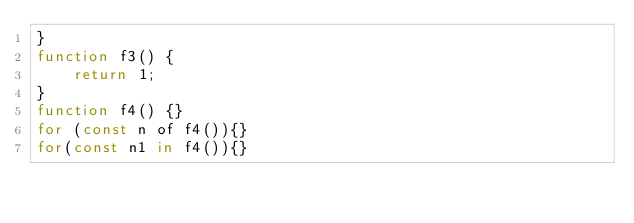<code> <loc_0><loc_0><loc_500><loc_500><_JavaScript_>}
function f3() {
    return 1;
}
function f4() {}
for (const n of f4()){}
for(const n1 in f4()){}
</code> 